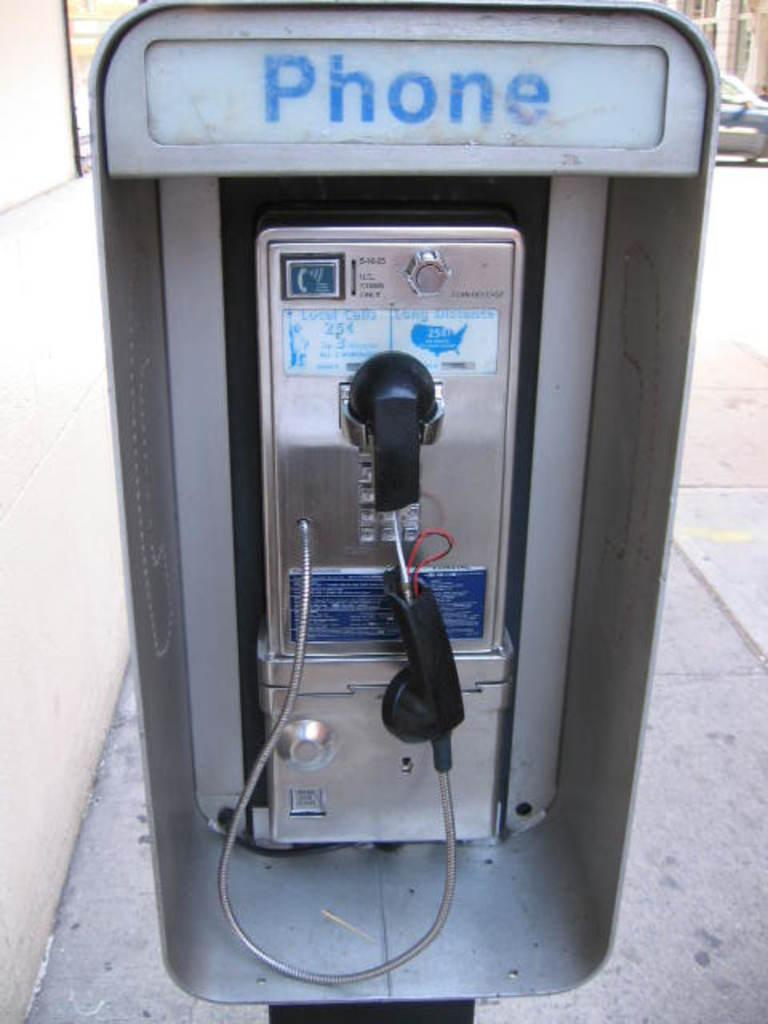<image>
Render a clear and concise summary of the photo. A broken public telephone occupies a booth marked PHONE. 